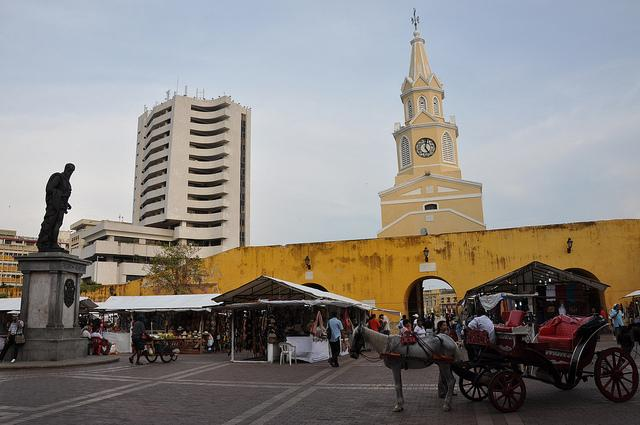Which structure was put up most recently? tent 